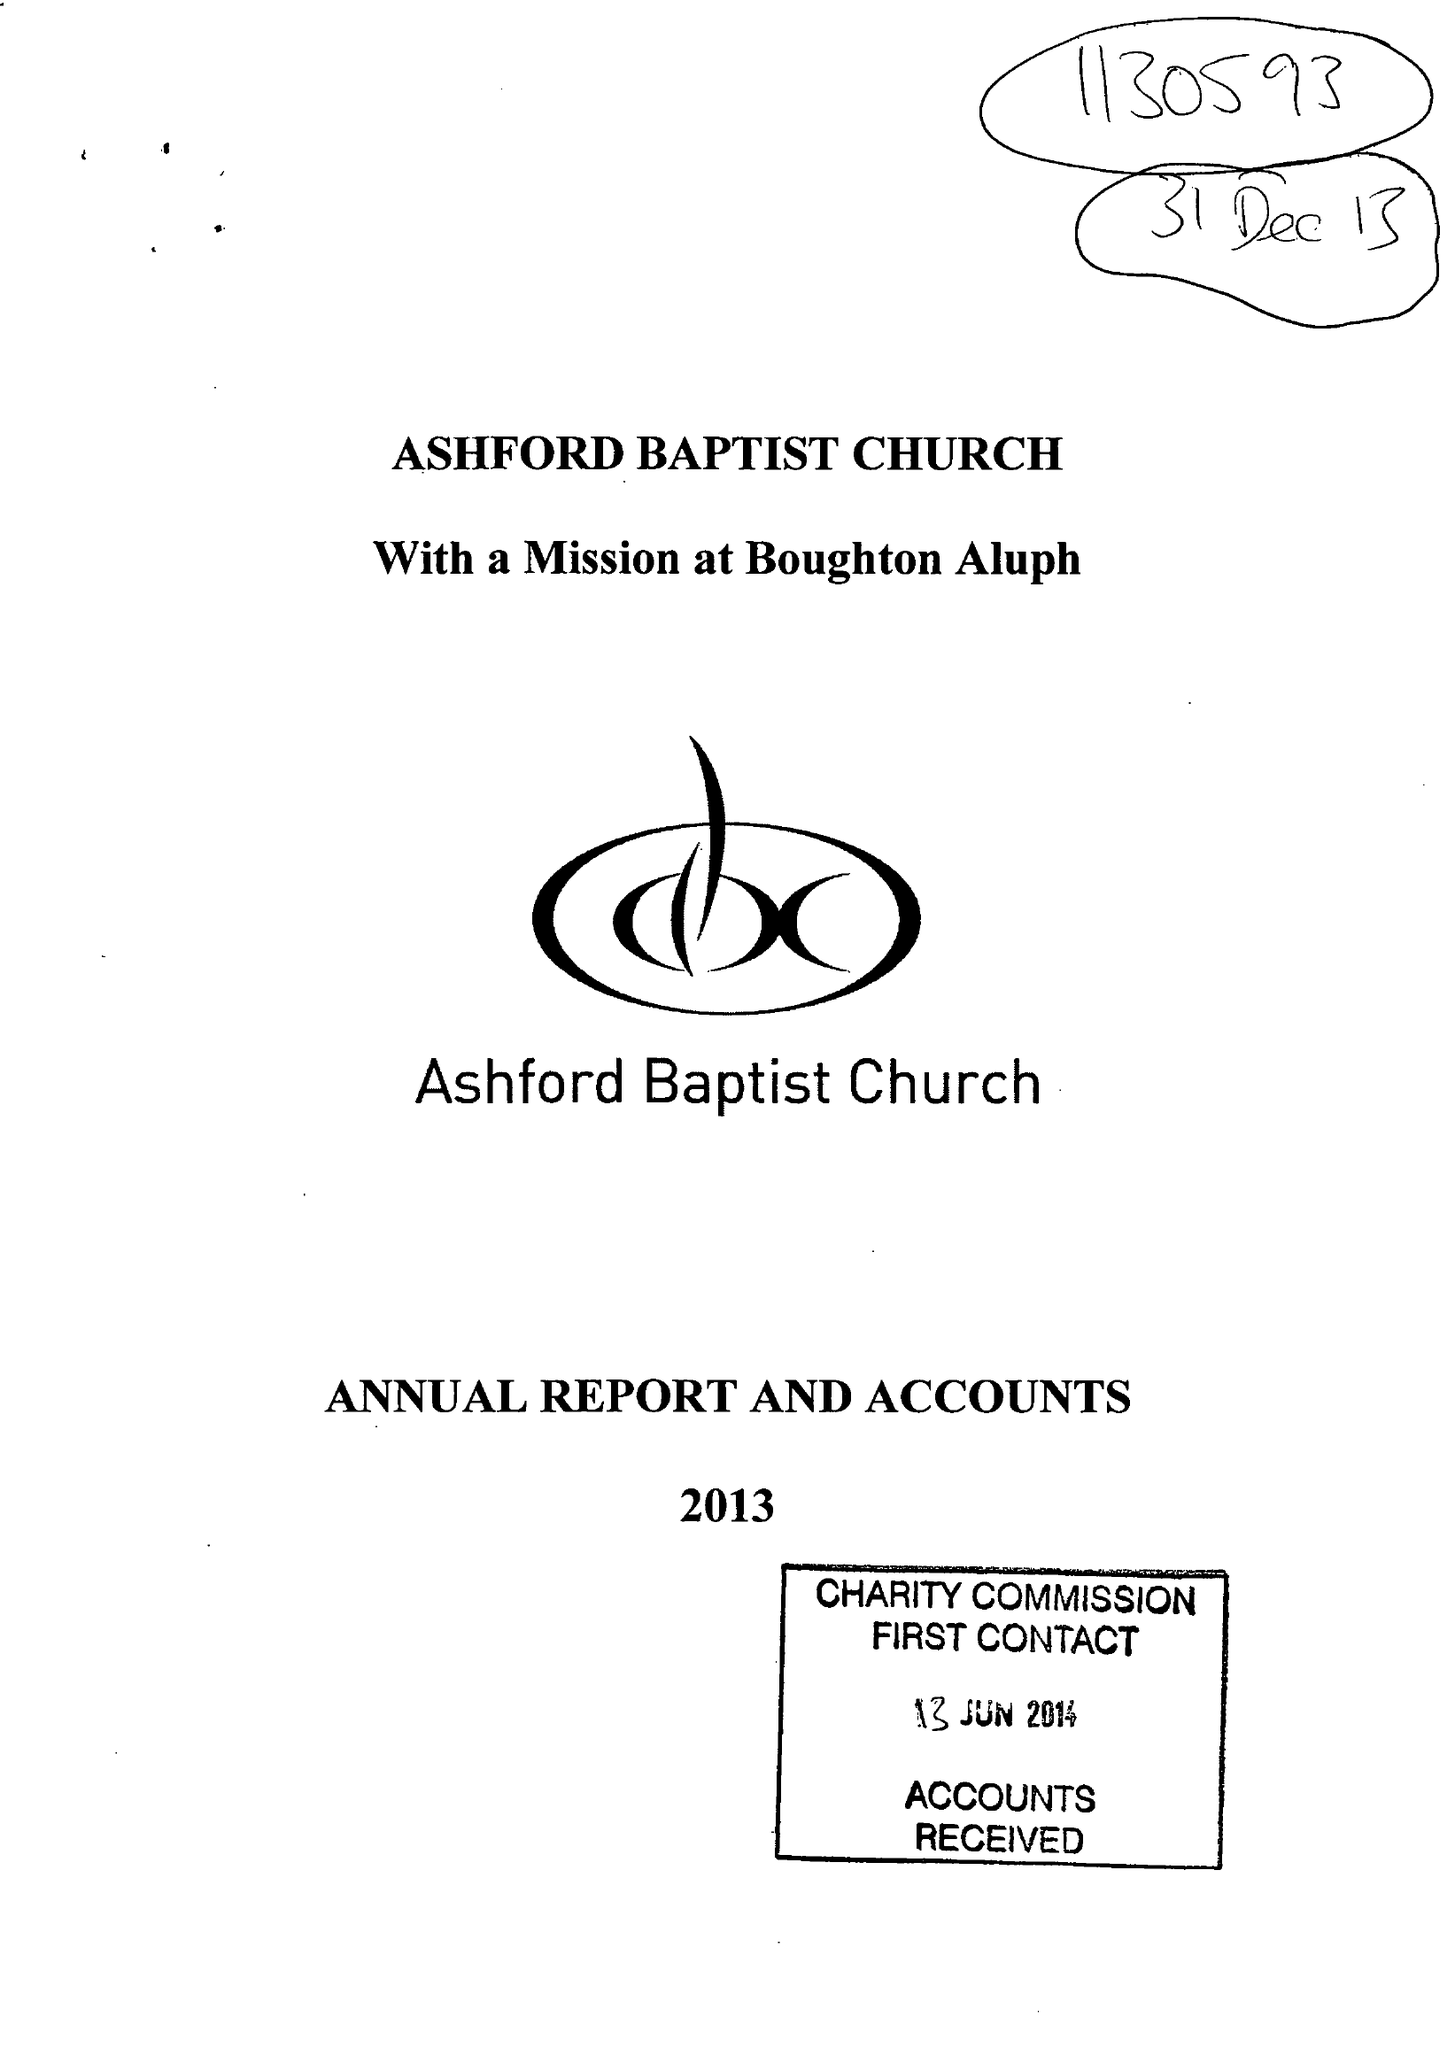What is the value for the report_date?
Answer the question using a single word or phrase. 2013-12-31 